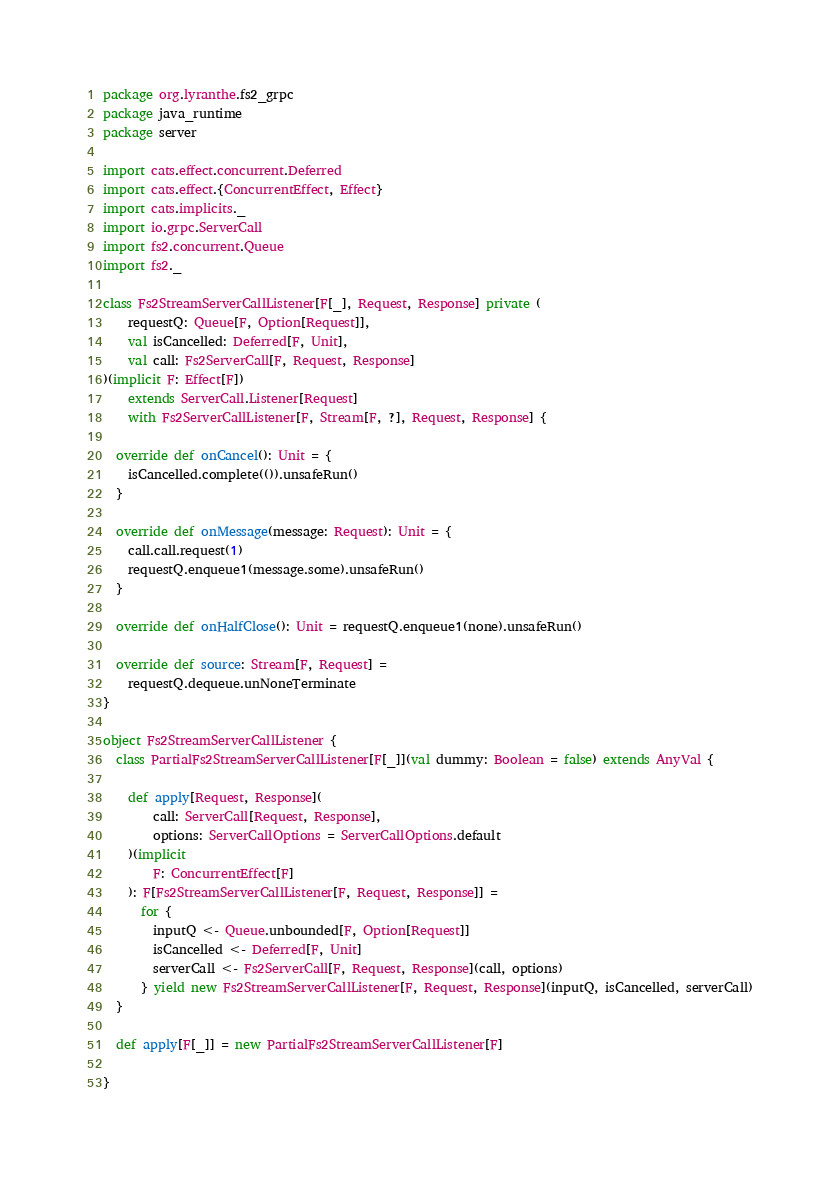Convert code to text. <code><loc_0><loc_0><loc_500><loc_500><_Scala_>package org.lyranthe.fs2_grpc
package java_runtime
package server

import cats.effect.concurrent.Deferred
import cats.effect.{ConcurrentEffect, Effect}
import cats.implicits._
import io.grpc.ServerCall
import fs2.concurrent.Queue
import fs2._

class Fs2StreamServerCallListener[F[_], Request, Response] private (
    requestQ: Queue[F, Option[Request]],
    val isCancelled: Deferred[F, Unit],
    val call: Fs2ServerCall[F, Request, Response]
)(implicit F: Effect[F])
    extends ServerCall.Listener[Request]
    with Fs2ServerCallListener[F, Stream[F, ?], Request, Response] {

  override def onCancel(): Unit = {
    isCancelled.complete(()).unsafeRun()
  }

  override def onMessage(message: Request): Unit = {
    call.call.request(1)
    requestQ.enqueue1(message.some).unsafeRun()
  }

  override def onHalfClose(): Unit = requestQ.enqueue1(none).unsafeRun()

  override def source: Stream[F, Request] =
    requestQ.dequeue.unNoneTerminate
}

object Fs2StreamServerCallListener {
  class PartialFs2StreamServerCallListener[F[_]](val dummy: Boolean = false) extends AnyVal {

    def apply[Request, Response](
        call: ServerCall[Request, Response],
        options: ServerCallOptions = ServerCallOptions.default
    )(implicit
        F: ConcurrentEffect[F]
    ): F[Fs2StreamServerCallListener[F, Request, Response]] =
      for {
        inputQ <- Queue.unbounded[F, Option[Request]]
        isCancelled <- Deferred[F, Unit]
        serverCall <- Fs2ServerCall[F, Request, Response](call, options)
      } yield new Fs2StreamServerCallListener[F, Request, Response](inputQ, isCancelled, serverCall)
  }

  def apply[F[_]] = new PartialFs2StreamServerCallListener[F]

}
</code> 